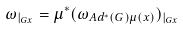<formula> <loc_0><loc_0><loc_500><loc_500>\omega _ { | _ { G x } } = \mu ^ { * } ( \omega _ { A d ^ { * } ( G ) \mu ( x ) } ) _ { | _ { G x } }</formula> 